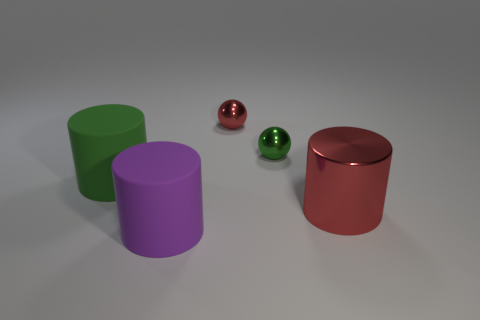Subtract all big purple rubber cylinders. How many cylinders are left? 2 Subtract 1 cylinders. How many cylinders are left? 2 Add 1 purple objects. How many objects exist? 6 Subtract all cylinders. How many objects are left? 2 Subtract all large purple metal spheres. Subtract all green rubber things. How many objects are left? 4 Add 2 small red metal things. How many small red metal things are left? 3 Add 1 big rubber cylinders. How many big rubber cylinders exist? 3 Subtract 0 green blocks. How many objects are left? 5 